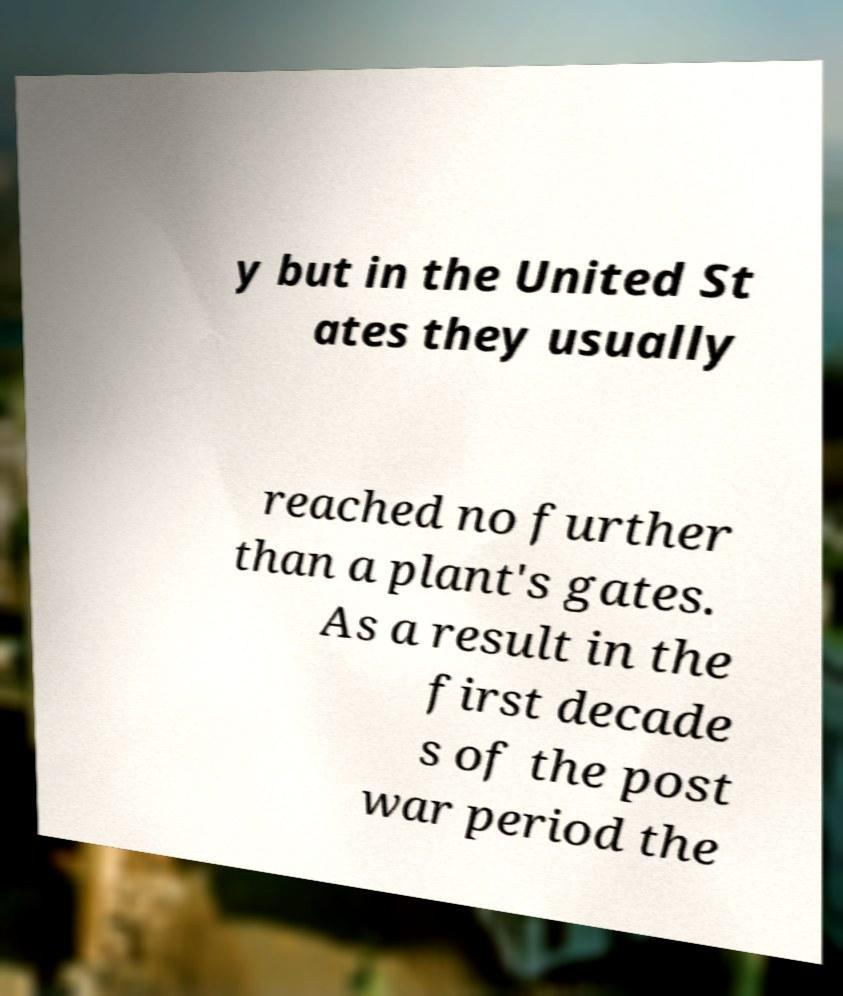Can you accurately transcribe the text from the provided image for me? y but in the United St ates they usually reached no further than a plant's gates. As a result in the first decade s of the post war period the 